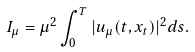Convert formula to latex. <formula><loc_0><loc_0><loc_500><loc_500>I _ { \mu } = \mu ^ { 2 } \int _ { 0 } ^ { T } | u _ { \mu } ( t , x _ { t } ) | ^ { 2 } d s .</formula> 